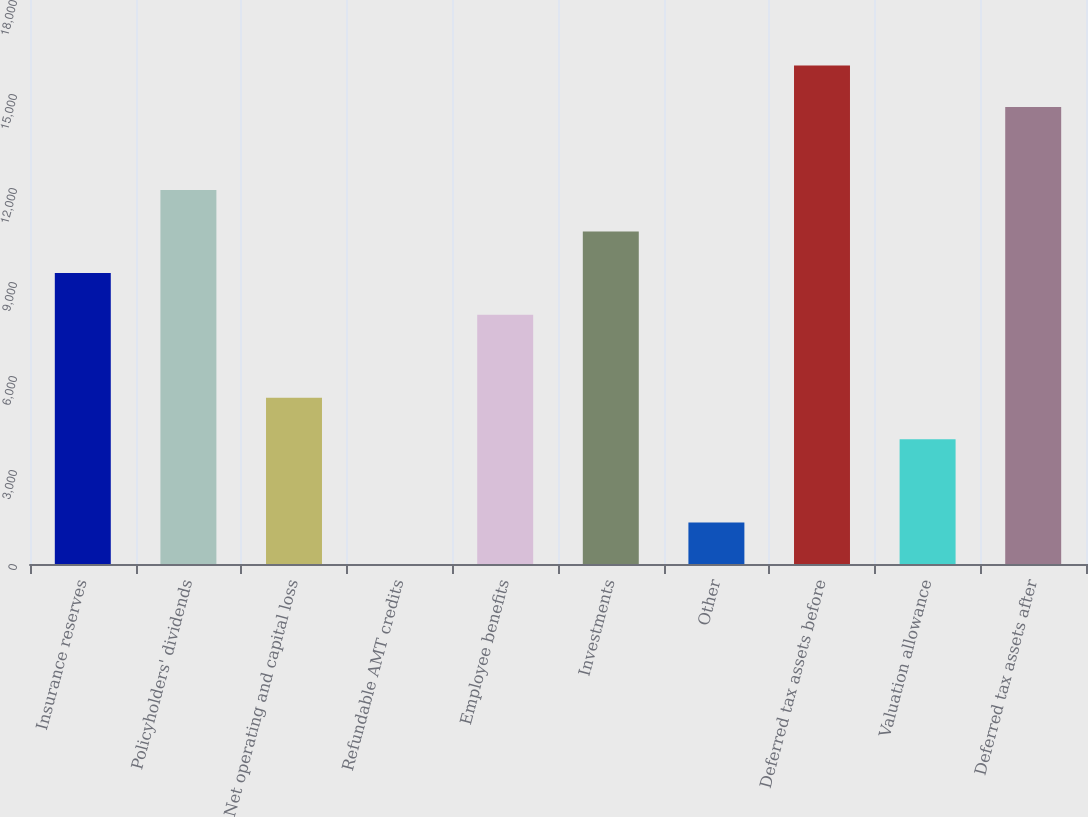<chart> <loc_0><loc_0><loc_500><loc_500><bar_chart><fcel>Insurance reserves<fcel>Policyholders' dividends<fcel>Net operating and capital loss<fcel>Refundable AMT credits<fcel>Employee benefits<fcel>Investments<fcel>Other<fcel>Deferred tax assets before<fcel>Valuation allowance<fcel>Deferred tax assets after<nl><fcel>9283.33<fcel>11935.1<fcel>5305.64<fcel>2.05<fcel>7957.44<fcel>10609.2<fcel>1327.95<fcel>15912.8<fcel>3979.74<fcel>14586.9<nl></chart> 